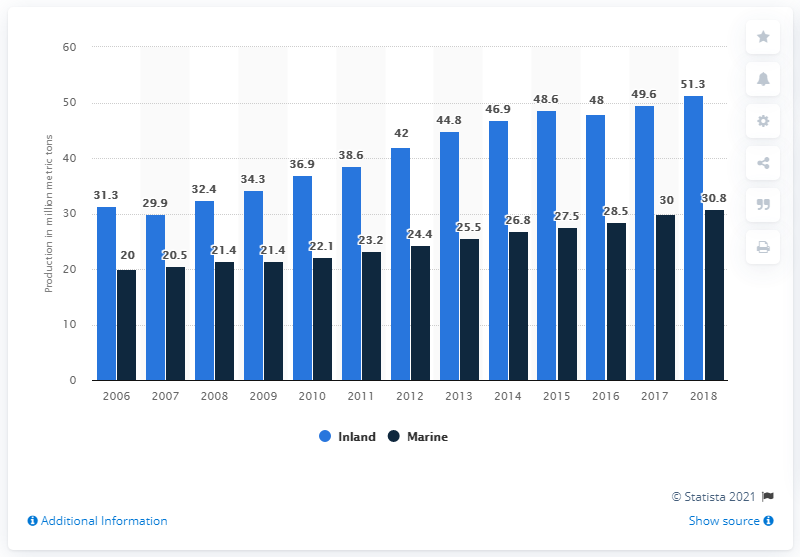Mention a couple of crucial points in this snapshot. In 2018, a total of 30.8 million metric tons of marine aquaculture products were produced worldwide. In 2018, a total of 51.3 metric tons of aquatic animals and plants were produced through inland aquaculture. 